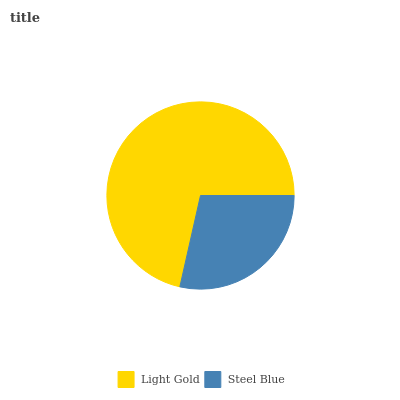Is Steel Blue the minimum?
Answer yes or no. Yes. Is Light Gold the maximum?
Answer yes or no. Yes. Is Steel Blue the maximum?
Answer yes or no. No. Is Light Gold greater than Steel Blue?
Answer yes or no. Yes. Is Steel Blue less than Light Gold?
Answer yes or no. Yes. Is Steel Blue greater than Light Gold?
Answer yes or no. No. Is Light Gold less than Steel Blue?
Answer yes or no. No. Is Light Gold the high median?
Answer yes or no. Yes. Is Steel Blue the low median?
Answer yes or no. Yes. Is Steel Blue the high median?
Answer yes or no. No. Is Light Gold the low median?
Answer yes or no. No. 